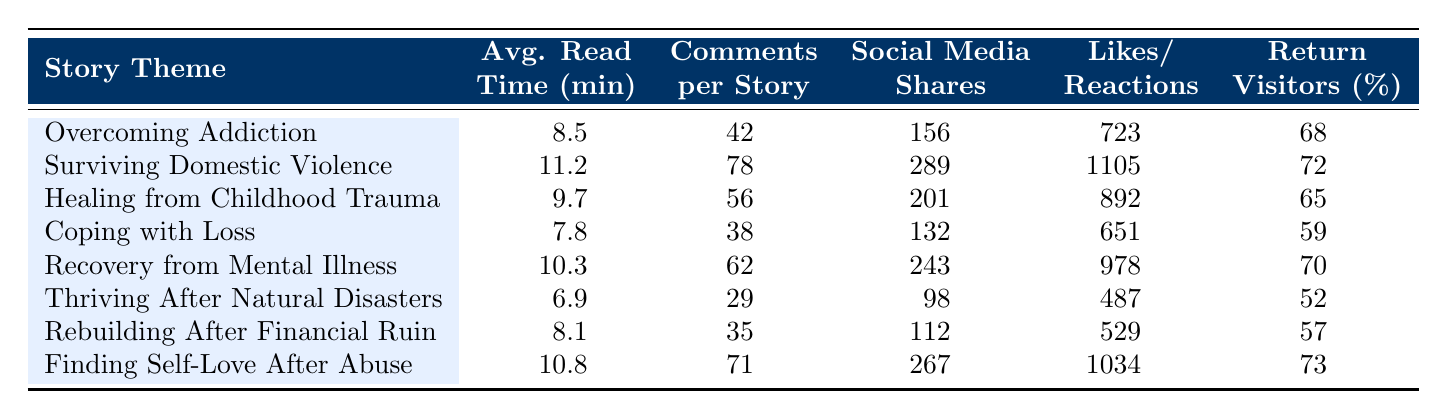What is the average read time for the theme "Surviving Domestic Violence"? The table indicates that the average read time for "Surviving Domestic Violence" is 11.2 minutes.
Answer: 11.2 minutes Which story theme has the highest number of comments per story? According to the table, "Surviving Domestic Violence" has the highest number of comments per story at 78.
Answer: Surviving Domestic Violence How many likes/reactions does the theme "Finding Self-Love After Abuse" receive? The table shows that "Finding Self-Love After Abuse" has 1034 likes/reactions.
Answer: 1034 What is the return visitor percentage for "Thriving After Natural Disasters"? The percentage of return visitors for "Thriving After Natural Disasters" is 52%, as specified in the table.
Answer: 52% Calculate the average read time of all story themes listed in the table. Adding all the average read times together (8.5 + 11.2 + 9.7 + 7.8 + 10.3 + 6.9 + 8.1 + 10.8) gives a total of 73.3. There are 8 themes, so the average read time is 73.3 / 8 = 9.1625 minutes.
Answer: 9.16 minutes Are there more shares on social media for "Recovery from Mental Illness" compared to "Coping with Loss"? The table shows that "Recovery from Mental Illness" has 243 shares, while "Coping with Loss" has 132 shares. Since 243 is greater than 132, the statement is true.
Answer: Yes Identify the theme with the least average read time and provide its value. By looking at the average read times, "Thriving After Natural Disasters" has the least average read time of 6.9 minutes.
Answer: 6.9 minutes What is the difference in likes/reactions between "Overcoming Addiction" and "Healing from Childhood Trauma"? "Overcoming Addiction" has 723 likes, while "Healing from Childhood Trauma" has 892 likes. The difference is 892 - 723 = 169 likes.
Answer: 169 Which theme has a higher percentage of return visitors, "Recovery from Mental Illness" or "Finding Self-Love After Abuse"? "Return Visitors (%)" for "Recovery from Mental Illness" is 70%, while for "Finding Self-Love After Abuse" it is 73%. Since 73% is greater than 70%, "Finding Self-Love After Abuse" has a higher percentage of return visitors.
Answer: Finding Self-Love After Abuse What is the total number of social media shares for the themes "Rebuilding After Financial Ruin" and "Coping with Loss"? The shares for "Rebuilding After Financial Ruin" is 112 and for "Coping with Loss" is 132. Adding these together gives 112 + 132 = 244 shares.
Answer: 244 shares 